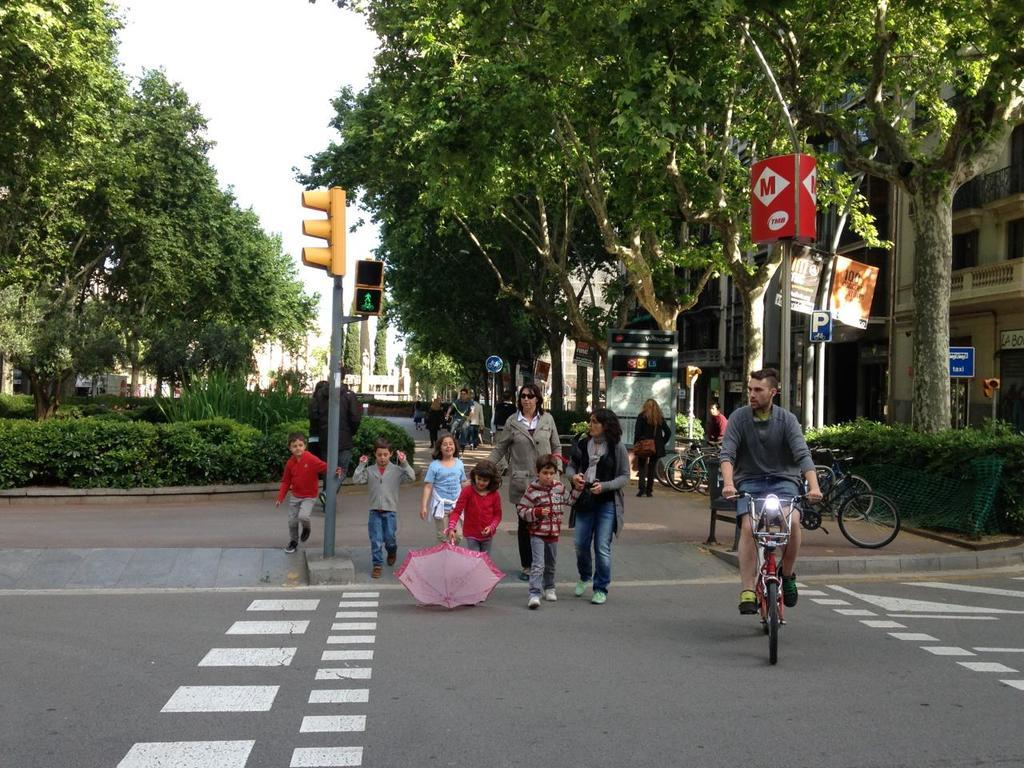<image>
Share a concise interpretation of the image provided. Family walking down a street next to a sign which has the letter M on it. 